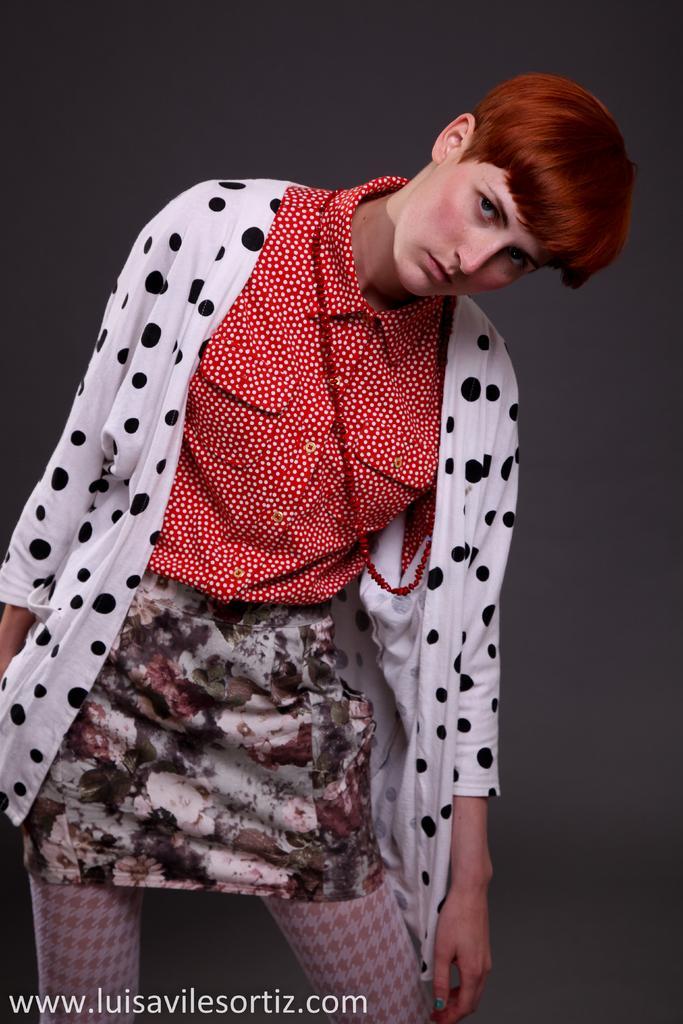Please provide a concise description of this image. In front of the image there is a person standing. Behind her there is a wall. There is some text at the bottom of the image. 